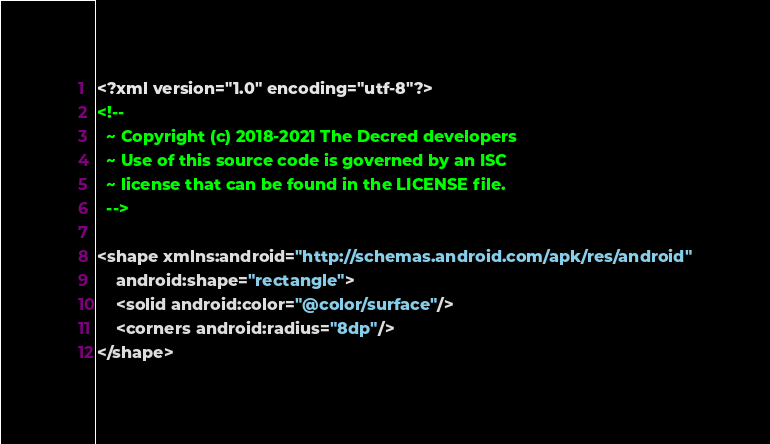<code> <loc_0><loc_0><loc_500><loc_500><_XML_><?xml version="1.0" encoding="utf-8"?>
<!--
  ~ Copyright (c) 2018-2021 The Decred developers
  ~ Use of this source code is governed by an ISC
  ~ license that can be found in the LICENSE file.
  -->

<shape xmlns:android="http://schemas.android.com/apk/res/android"
    android:shape="rectangle">
    <solid android:color="@color/surface"/>
    <corners android:radius="8dp"/>
</shape></code> 